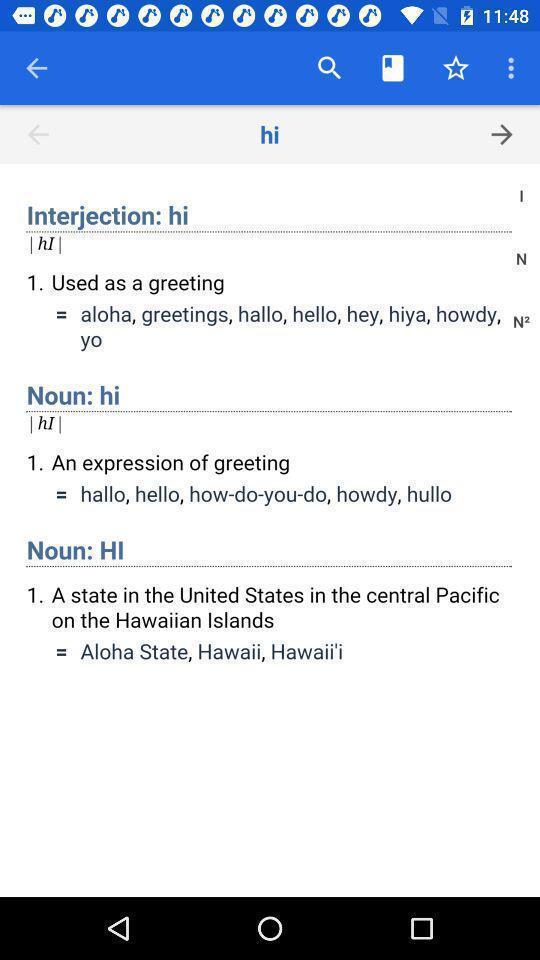Provide a detailed account of this screenshot. Searching a meaning of a word. 